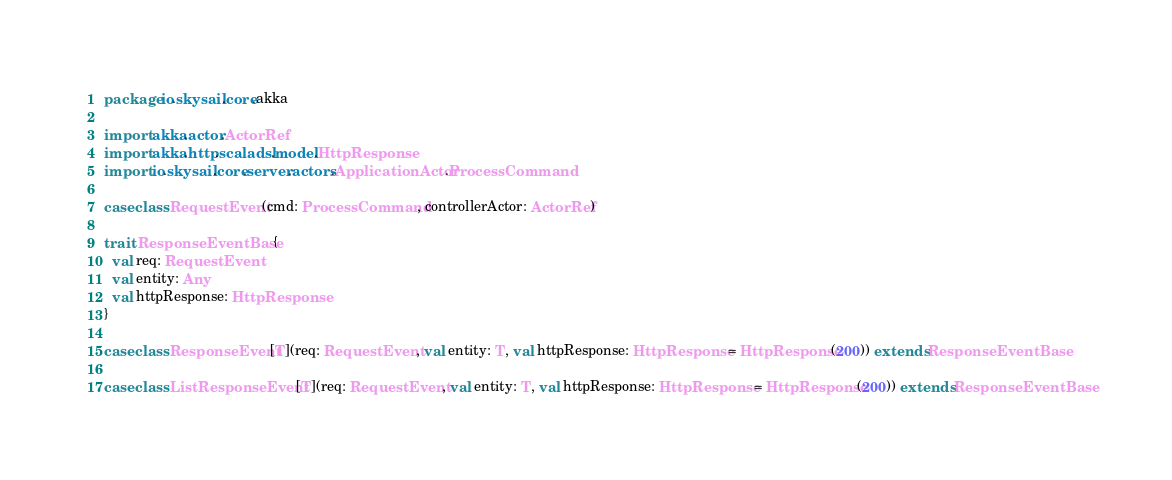<code> <loc_0><loc_0><loc_500><loc_500><_Scala_>package io.skysail.core.akka

import akka.actor.ActorRef
import akka.http.scaladsl.model.HttpResponse
import io.skysail.core.server.actors.ApplicationActor.ProcessCommand

case class RequestEvent(cmd: ProcessCommand, controllerActor: ActorRef)

trait ResponseEventBase {
  val req: RequestEvent
  val entity: Any
  val httpResponse: HttpResponse
}

case class ResponseEvent[T](req: RequestEvent, val entity: T, val httpResponse: HttpResponse = HttpResponse(200)) extends ResponseEventBase

case class ListResponseEvent[T](req: RequestEvent, val entity: T, val httpResponse: HttpResponse = HttpResponse(200)) extends ResponseEventBase</code> 